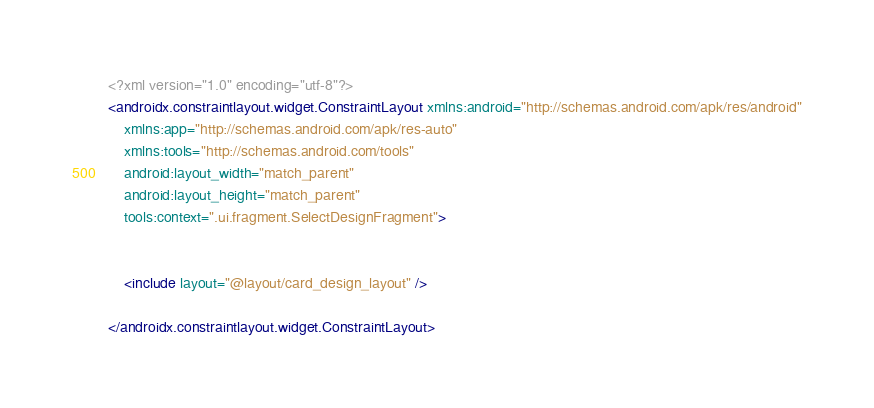<code> <loc_0><loc_0><loc_500><loc_500><_XML_><?xml version="1.0" encoding="utf-8"?>
<androidx.constraintlayout.widget.ConstraintLayout xmlns:android="http://schemas.android.com/apk/res/android"
    xmlns:app="http://schemas.android.com/apk/res-auto"
    xmlns:tools="http://schemas.android.com/tools"
    android:layout_width="match_parent"
    android:layout_height="match_parent"
    tools:context=".ui.fragment.SelectDesignFragment">


    <include layout="@layout/card_design_layout" />

</androidx.constraintlayout.widget.ConstraintLayout></code> 